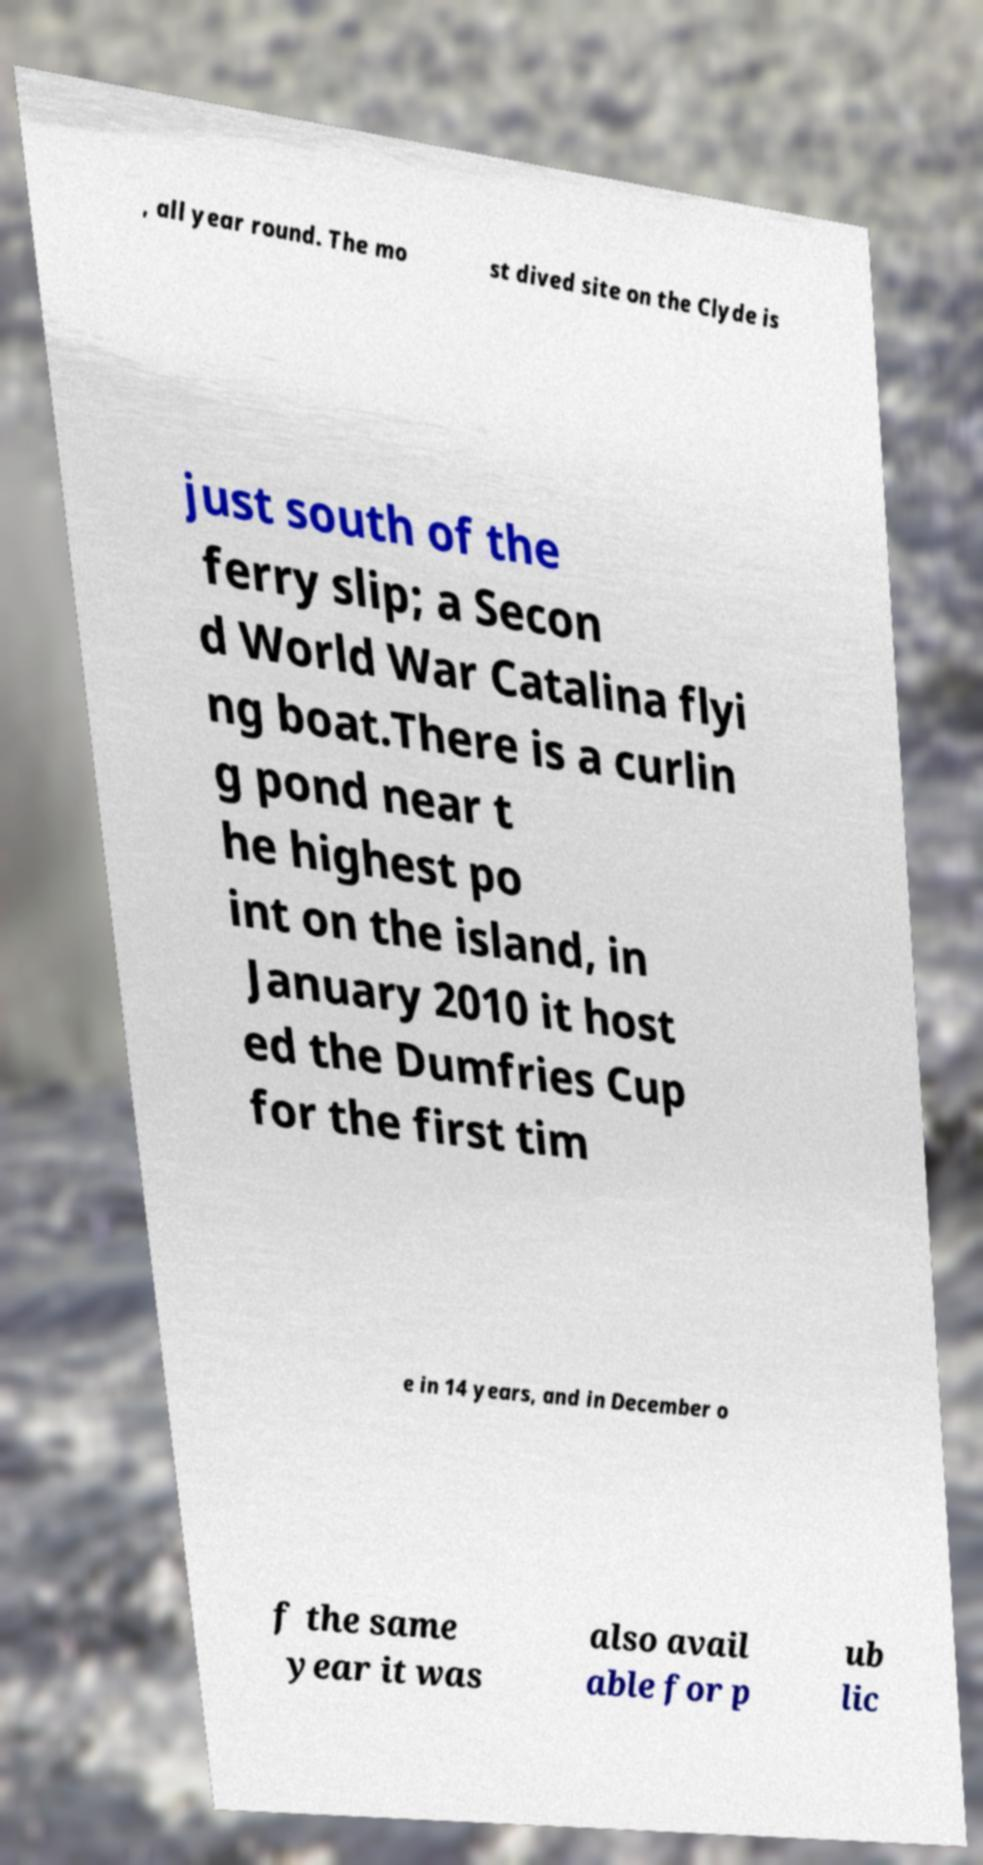Could you extract and type out the text from this image? , all year round. The mo st dived site on the Clyde is just south of the ferry slip; a Secon d World War Catalina flyi ng boat.There is a curlin g pond near t he highest po int on the island, in January 2010 it host ed the Dumfries Cup for the first tim e in 14 years, and in December o f the same year it was also avail able for p ub lic 